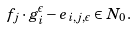Convert formula to latex. <formula><loc_0><loc_0><loc_500><loc_500>f _ { j } \cdot g _ { i } ^ { \epsilon } - e _ { i , j , \epsilon } \in N _ { 0 } .</formula> 